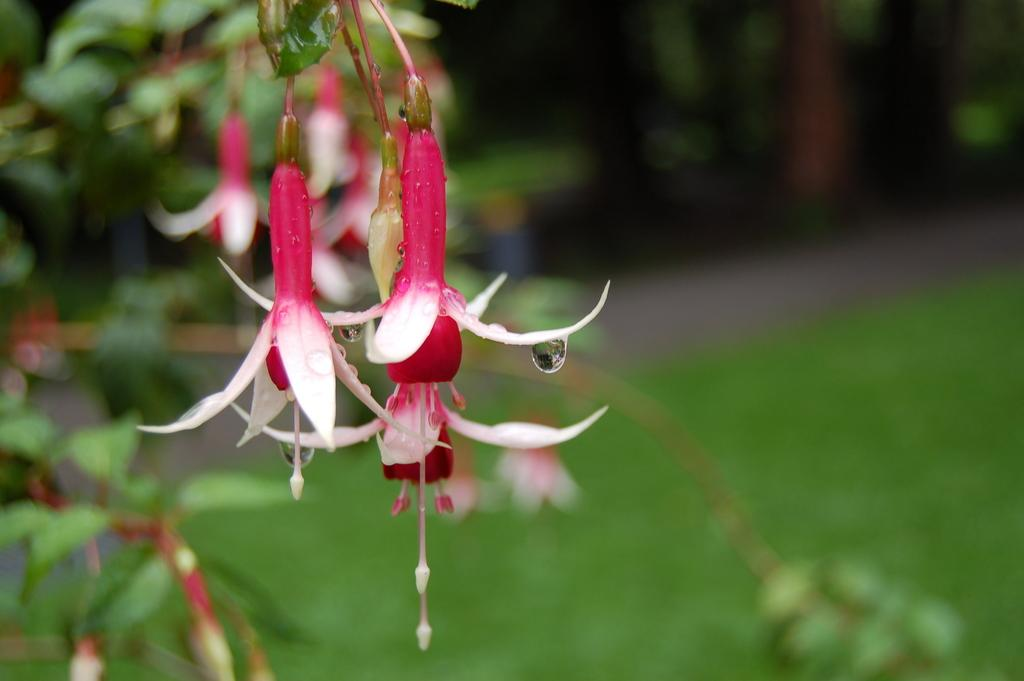What colors are the flowers in the image? The flowers in the image are pink and white. What can be observed on the flowers? The flowers have water droplets on them. What is the background of the image? The background of the image is green and blurred. What type of wound can be seen on the flowers in the image? There are no wounds visible on the flowers in the image. 